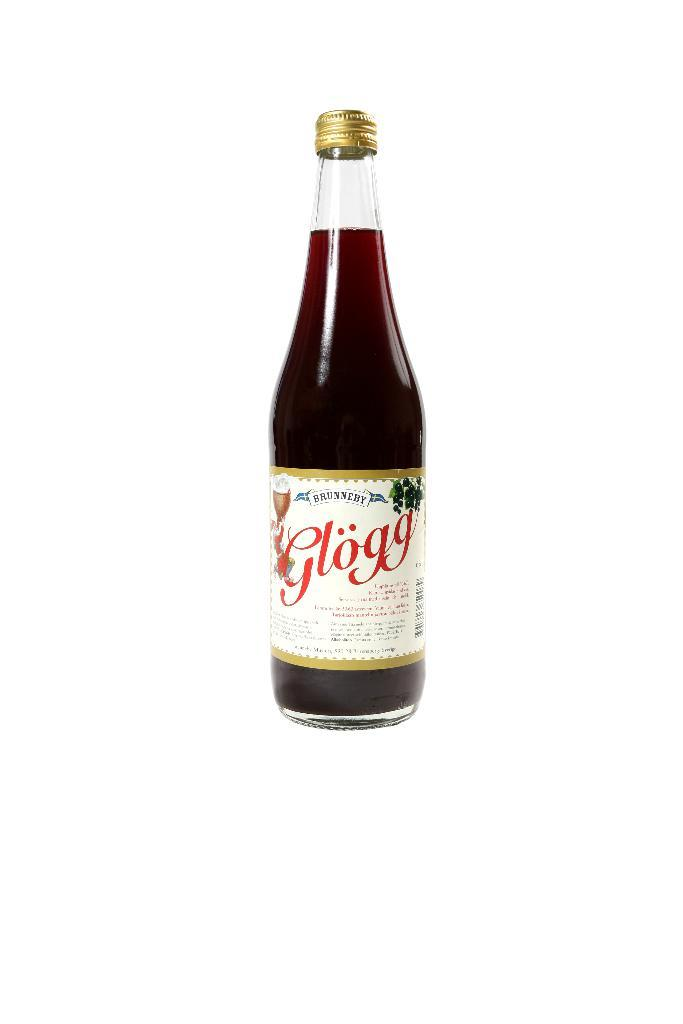<image>
Offer a succinct explanation of the picture presented. A bottle of Brunneby Glogg alcohol on a white background. 